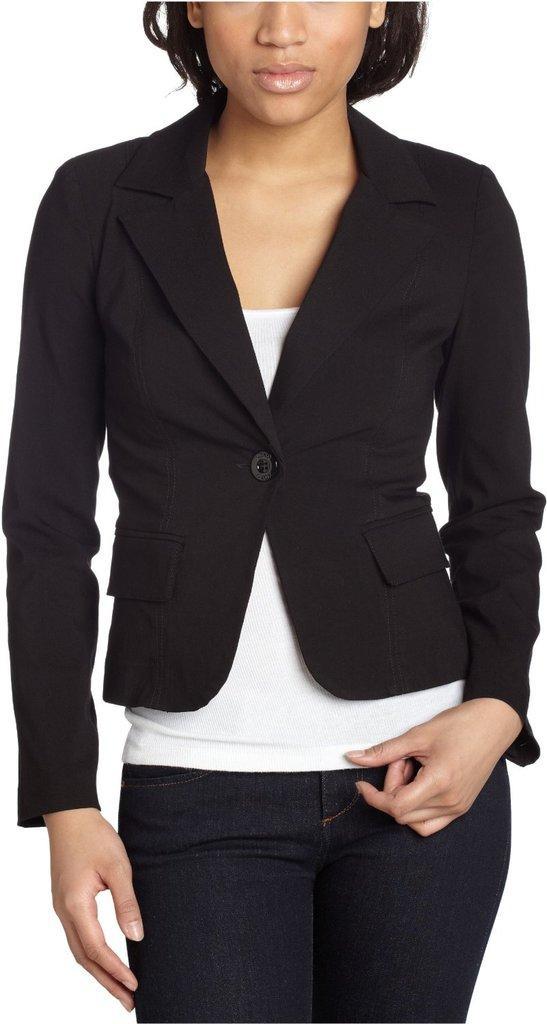In one or two sentences, can you explain what this image depicts? In this image, I can see a person standing. There is a white background. 